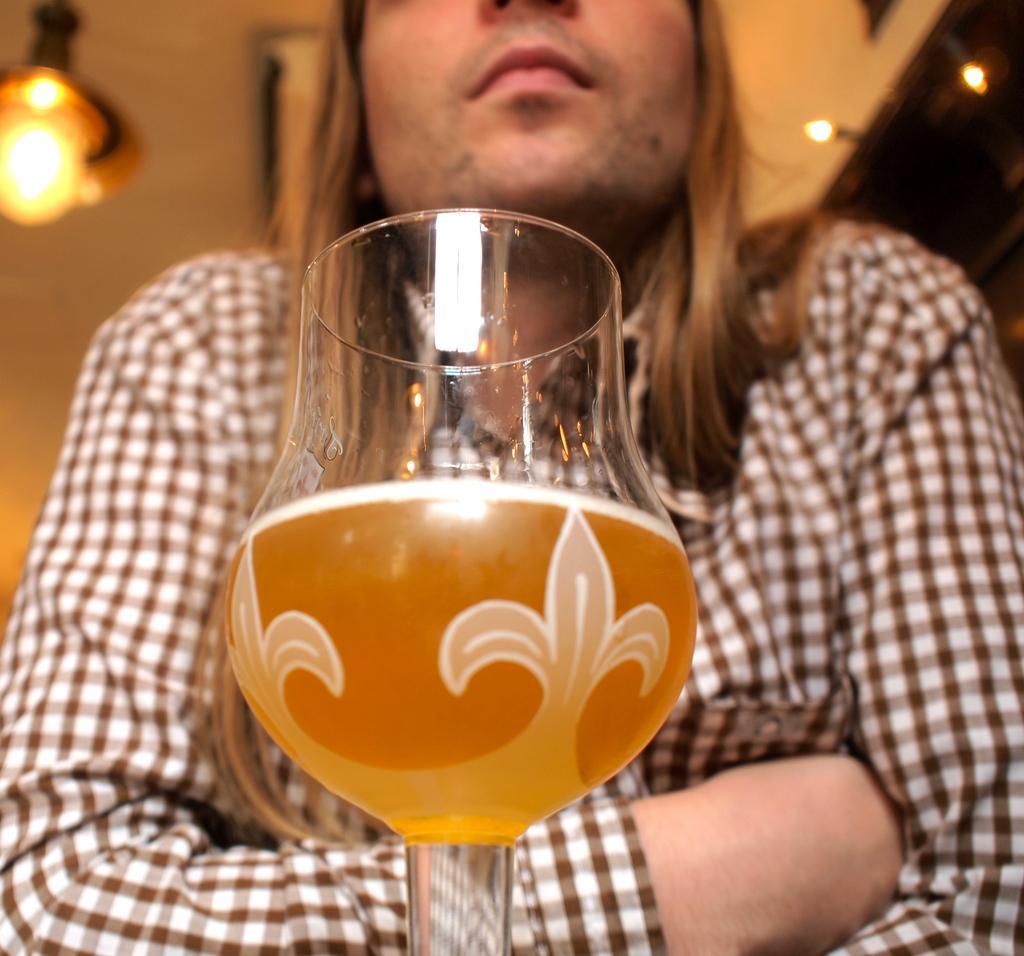Please provide a concise description of this image. This image consists of a person. There is a glass in front of him. There is some liquid in that glass. 